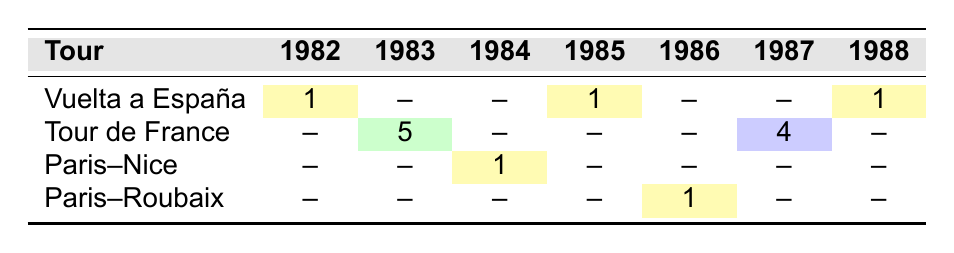What year did Sean Kelly achieve first place in the Vuelta a España? In the table, Sean Kelly finished first in the Vuelta a España in the years 1982, 1985, and 1988. Thus, the answer to this question can refer to the first occurrence, which is 1982.
Answer: 1982 How many times did Sean Kelly finish in first place in major cycling tours from 1982 to 1988? By looking at the table, we can see that Sean Kelly finished first in the Vuelta a España (1982, 1985), Paris–Nice (1984), and Paris–Roubaix (1986), totaling 4 first-place finishes.
Answer: 4 Which tour did Sean Kelly finish in 5th place, and in what year? The table shows that in 1983, he finished 5th in the Tour de France. This directly answers the question as both the tour and year are clear in the data.
Answer: Tour de France, 1983 Did Sean Kelly ever finish in the top five of the Paris–Roubaix? According to the table, Sean Kelly finished first in the Paris–Roubaix in 1986, which is a top place, but there’s no fifth place mentioned. Therefore, he did not finish in the top five in this tour other than first.
Answer: No What is the total number of times Sean Kelly participated in a major cycling tour from 1982 to 1988? By counting the entries in the table, there are 7 tours listed (one for each year). Therefore, we can conclude that Sean Kelly participated in a major cycling tour every year from 1982 to 1988.
Answer: 7 Which tour saw the highest finish of Sean Kelly in terms of position? The finishes for Sean Kelly in each listed tour are: Vuelta a España: 1st (1982, 1985, 1988), Tour de France: 5th (1983) and 4th (1987), Paris–Nice: 1st (1984), and Paris–Roubaix: 1st (1986). Since 1st place is the highest position and he achieved it multiple times, the answer is the tours where he finished 1st, including Vuelta a España and Paris–Roubaix.
Answer: Vuelta a España, Paris–Roubaix In which tours did Sean Kelly not finish in the top three? From the table, he finished in the following positions: Vuelta a España: 1st (1982, 1985, 1988), Tour de France: 5th (1983) and 4th (1987), Paris–Nice: 1st (1984), and Paris–Roubaix: 1st (1986). The tours where he finished outside the top three are the Tour de France in 1983 and 1987.
Answer: Tour de France in 1983 and 1987 What was Sean Kelly's average finish position across all tours from 1982 to 1988? To calculate the average, we need to add the positions: (1 + 5 + 1 + 1 + 1 + 4 + 1) = 14. There are 7 tours, so we divide 14 by 7 to find the average: 14/7 = 2.
Answer: 2 